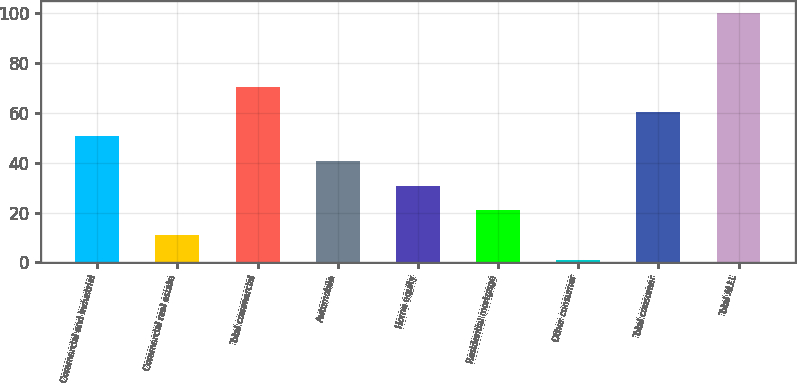<chart> <loc_0><loc_0><loc_500><loc_500><bar_chart><fcel>Commercial and industrial<fcel>Commercial real estate<fcel>Total commercial<fcel>Automobile<fcel>Home equity<fcel>Residential mortgage<fcel>Other consumer<fcel>Total consumer<fcel>Total ALLL<nl><fcel>50.6<fcel>11<fcel>70.4<fcel>40.7<fcel>30.8<fcel>20.9<fcel>1<fcel>60.5<fcel>100<nl></chart> 